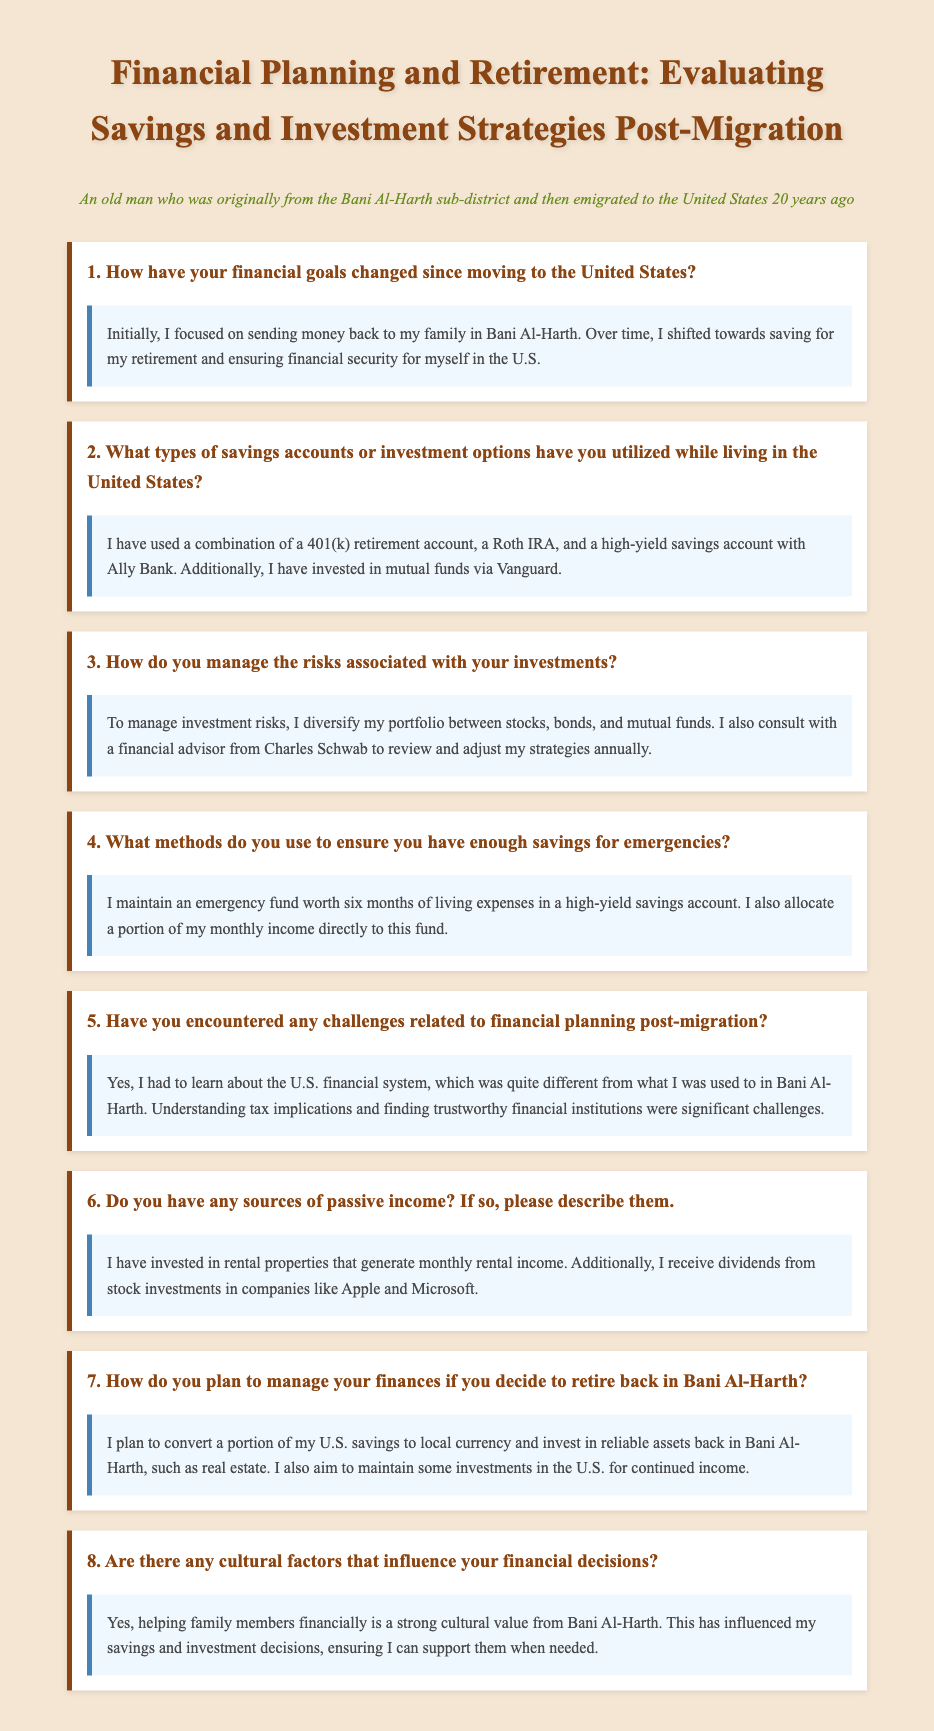What types of accounts have been utilized? The document lists the specific financial accounts the individual has used while living in the U.S., including a 401(k), Roth IRA, high-yield savings account, and mutual funds.
Answer: 401(k), Roth IRA, high-yield savings account, mutual funds How long has the individual emigrated to the United States? The document states that the individual emigrated to the U.S. 20 years ago, which is a specific duration.
Answer: 20 years What is the purpose of the emergency fund mentioned? The document indicates the purpose of the emergency fund, which is to cover living expenses during unforeseen circumstances.
Answer: To cover six months of living expenses Which financial institution does the individual consult for investment advice? The document explicitly mentions the financial institution that the individual consults, which helps them manage investment risks.
Answer: Charles Schwab What cultural influence affects the individual's financial decisions? The document highlights a specific cultural value that impacts the individual's approach to financial planning, particularly regarding family.
Answer: Helping family members financially How does the individual plan to invest if they retire in Bani Al-Harth? The document includes details about the individual's strategy for managing finances upon potential return to their home region, specifically mentioning asset investment.
Answer: Convert savings to local currency and invest in real estate 